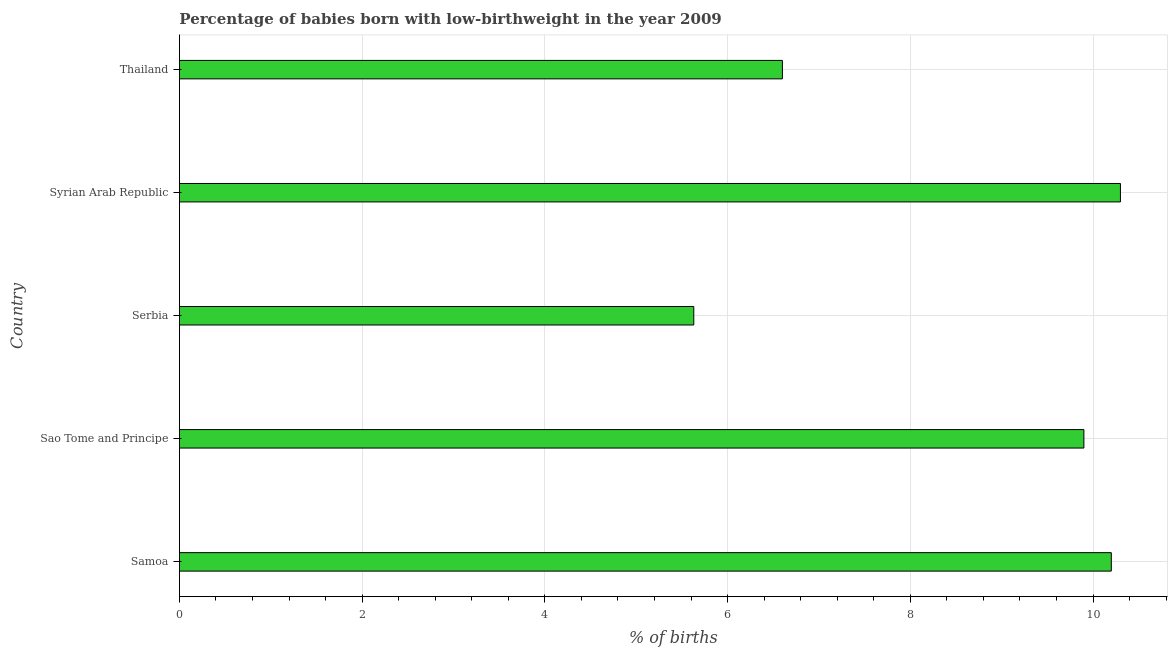What is the title of the graph?
Your response must be concise. Percentage of babies born with low-birthweight in the year 2009. What is the label or title of the X-axis?
Offer a terse response. % of births. Across all countries, what is the maximum percentage of babies who were born with low-birthweight?
Make the answer very short. 10.3. Across all countries, what is the minimum percentage of babies who were born with low-birthweight?
Your answer should be very brief. 5.63. In which country was the percentage of babies who were born with low-birthweight maximum?
Give a very brief answer. Syrian Arab Republic. In which country was the percentage of babies who were born with low-birthweight minimum?
Your response must be concise. Serbia. What is the sum of the percentage of babies who were born with low-birthweight?
Offer a very short reply. 42.63. What is the difference between the percentage of babies who were born with low-birthweight in Samoa and Serbia?
Your response must be concise. 4.57. What is the average percentage of babies who were born with low-birthweight per country?
Keep it short and to the point. 8.53. In how many countries, is the percentage of babies who were born with low-birthweight greater than 10 %?
Your response must be concise. 2. What is the ratio of the percentage of babies who were born with low-birthweight in Serbia to that in Syrian Arab Republic?
Provide a succinct answer. 0.55. Is the sum of the percentage of babies who were born with low-birthweight in Sao Tome and Principe and Syrian Arab Republic greater than the maximum percentage of babies who were born with low-birthweight across all countries?
Give a very brief answer. Yes. What is the difference between the highest and the lowest percentage of babies who were born with low-birthweight?
Offer a terse response. 4.67. In how many countries, is the percentage of babies who were born with low-birthweight greater than the average percentage of babies who were born with low-birthweight taken over all countries?
Your answer should be very brief. 3. How many bars are there?
Give a very brief answer. 5. Are all the bars in the graph horizontal?
Provide a short and direct response. Yes. Are the values on the major ticks of X-axis written in scientific E-notation?
Provide a short and direct response. No. What is the % of births in Samoa?
Make the answer very short. 10.2. What is the % of births in Serbia?
Offer a very short reply. 5.63. What is the % of births of Thailand?
Ensure brevity in your answer.  6.6. What is the difference between the % of births in Samoa and Serbia?
Your answer should be very brief. 4.57. What is the difference between the % of births in Samoa and Thailand?
Ensure brevity in your answer.  3.6. What is the difference between the % of births in Sao Tome and Principe and Serbia?
Make the answer very short. 4.27. What is the difference between the % of births in Sao Tome and Principe and Syrian Arab Republic?
Provide a succinct answer. -0.4. What is the difference between the % of births in Serbia and Syrian Arab Republic?
Keep it short and to the point. -4.67. What is the difference between the % of births in Serbia and Thailand?
Your answer should be compact. -0.97. What is the difference between the % of births in Syrian Arab Republic and Thailand?
Offer a very short reply. 3.7. What is the ratio of the % of births in Samoa to that in Serbia?
Ensure brevity in your answer.  1.81. What is the ratio of the % of births in Samoa to that in Thailand?
Your answer should be compact. 1.54. What is the ratio of the % of births in Sao Tome and Principe to that in Serbia?
Make the answer very short. 1.76. What is the ratio of the % of births in Sao Tome and Principe to that in Syrian Arab Republic?
Your response must be concise. 0.96. What is the ratio of the % of births in Sao Tome and Principe to that in Thailand?
Keep it short and to the point. 1.5. What is the ratio of the % of births in Serbia to that in Syrian Arab Republic?
Your answer should be compact. 0.55. What is the ratio of the % of births in Serbia to that in Thailand?
Your answer should be very brief. 0.85. What is the ratio of the % of births in Syrian Arab Republic to that in Thailand?
Ensure brevity in your answer.  1.56. 